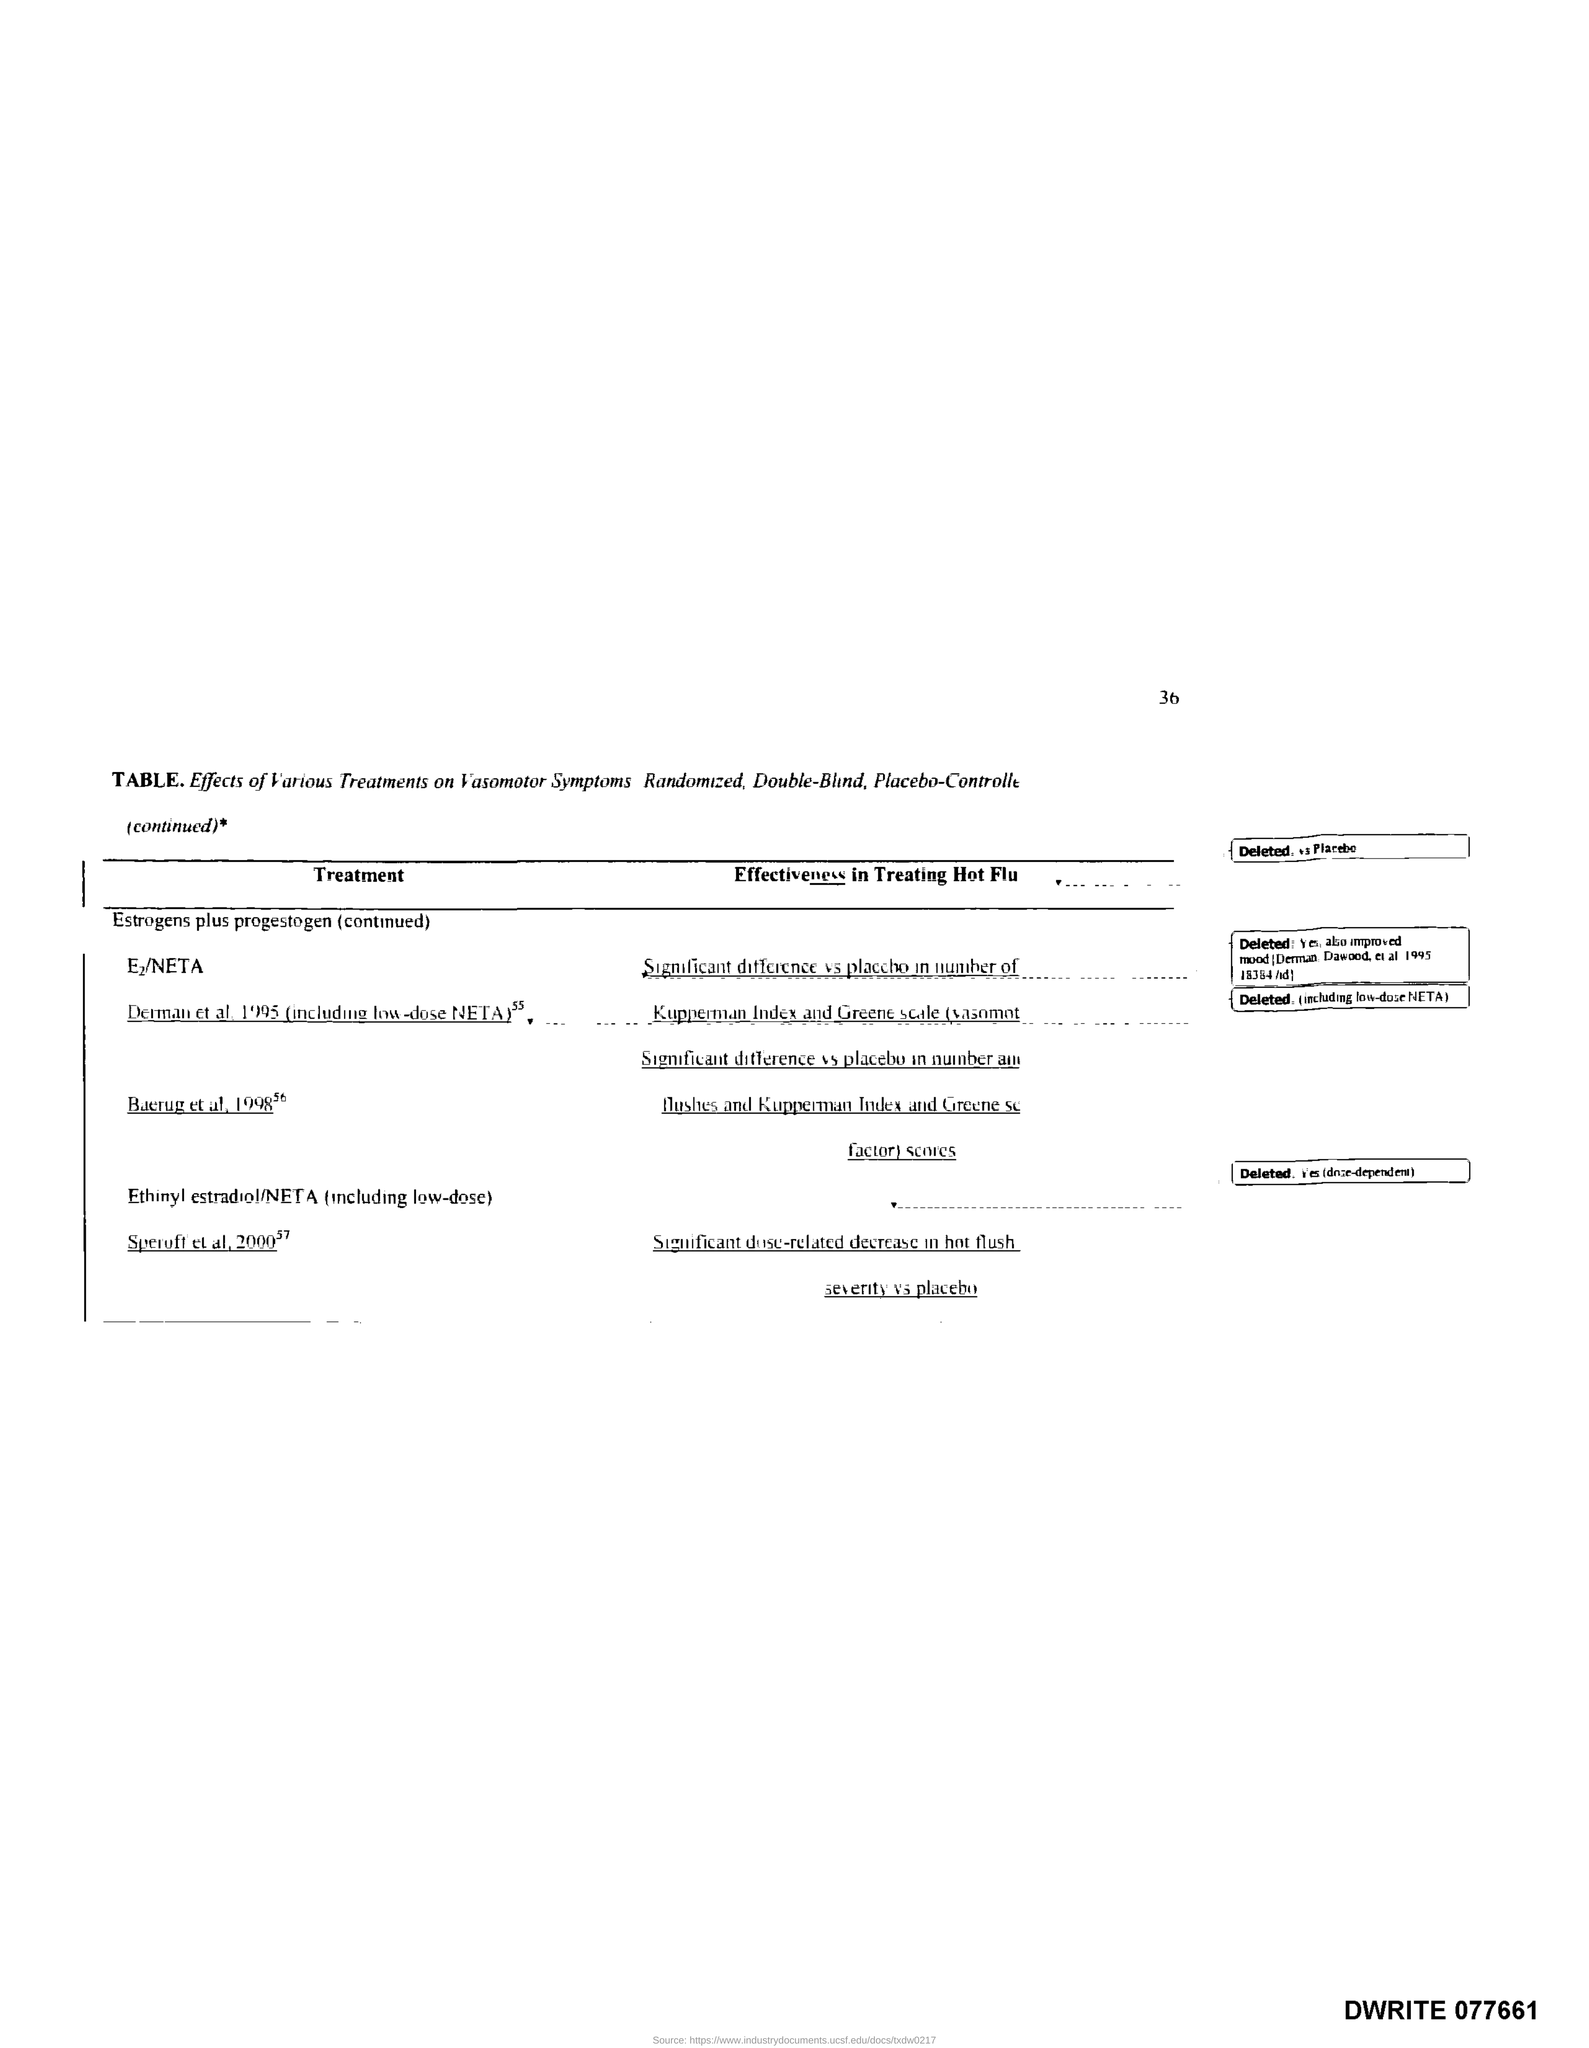Point out several critical features in this image. I have located the relevant page and it is number 36. 